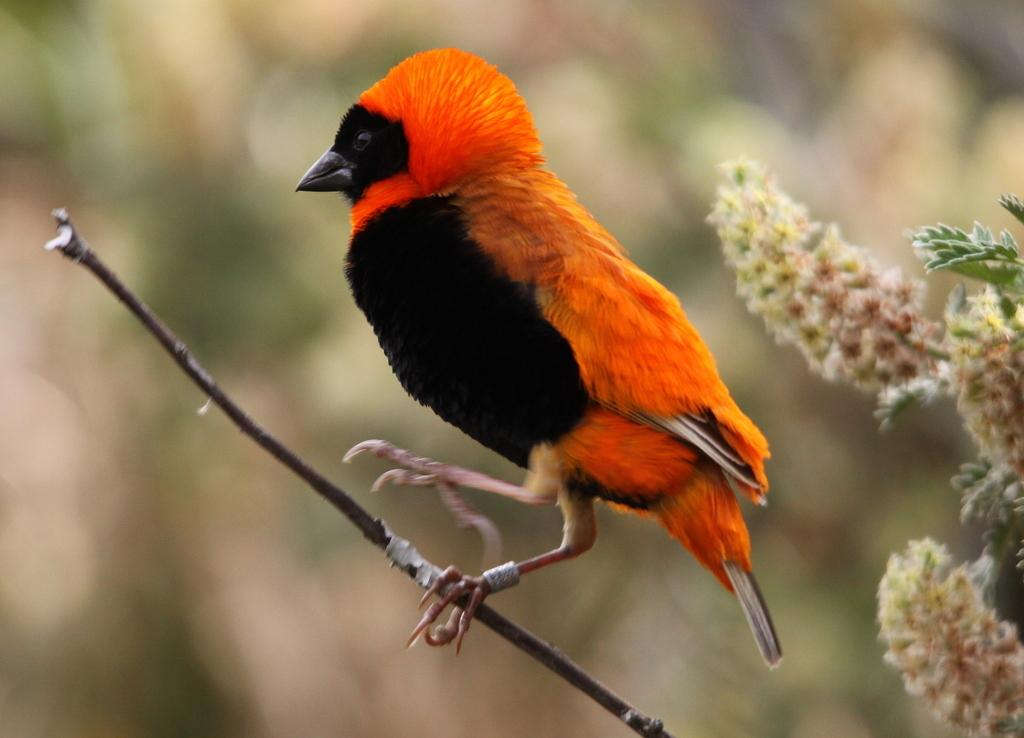What type of animal can be seen in the image? There is a bird in the image. Where is the bird located in the image? The bird is sitting on a wooden stick. What other elements are present in the image besides the bird? There are flowers in the image. How would you describe the background of the image? The background of the image is blurred. What toys does the bird have in the image? There are no toys present in the image; it features a bird sitting on a wooden stick with flowers in the background. 